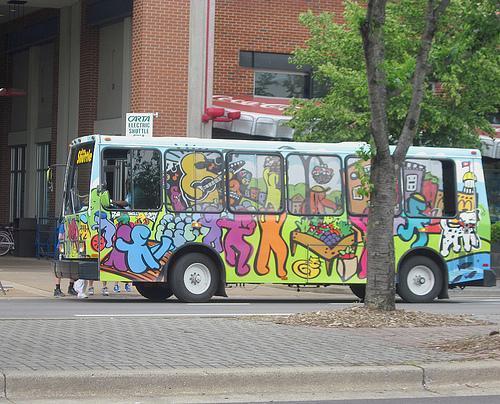How many buses are there?
Give a very brief answer. 1. 